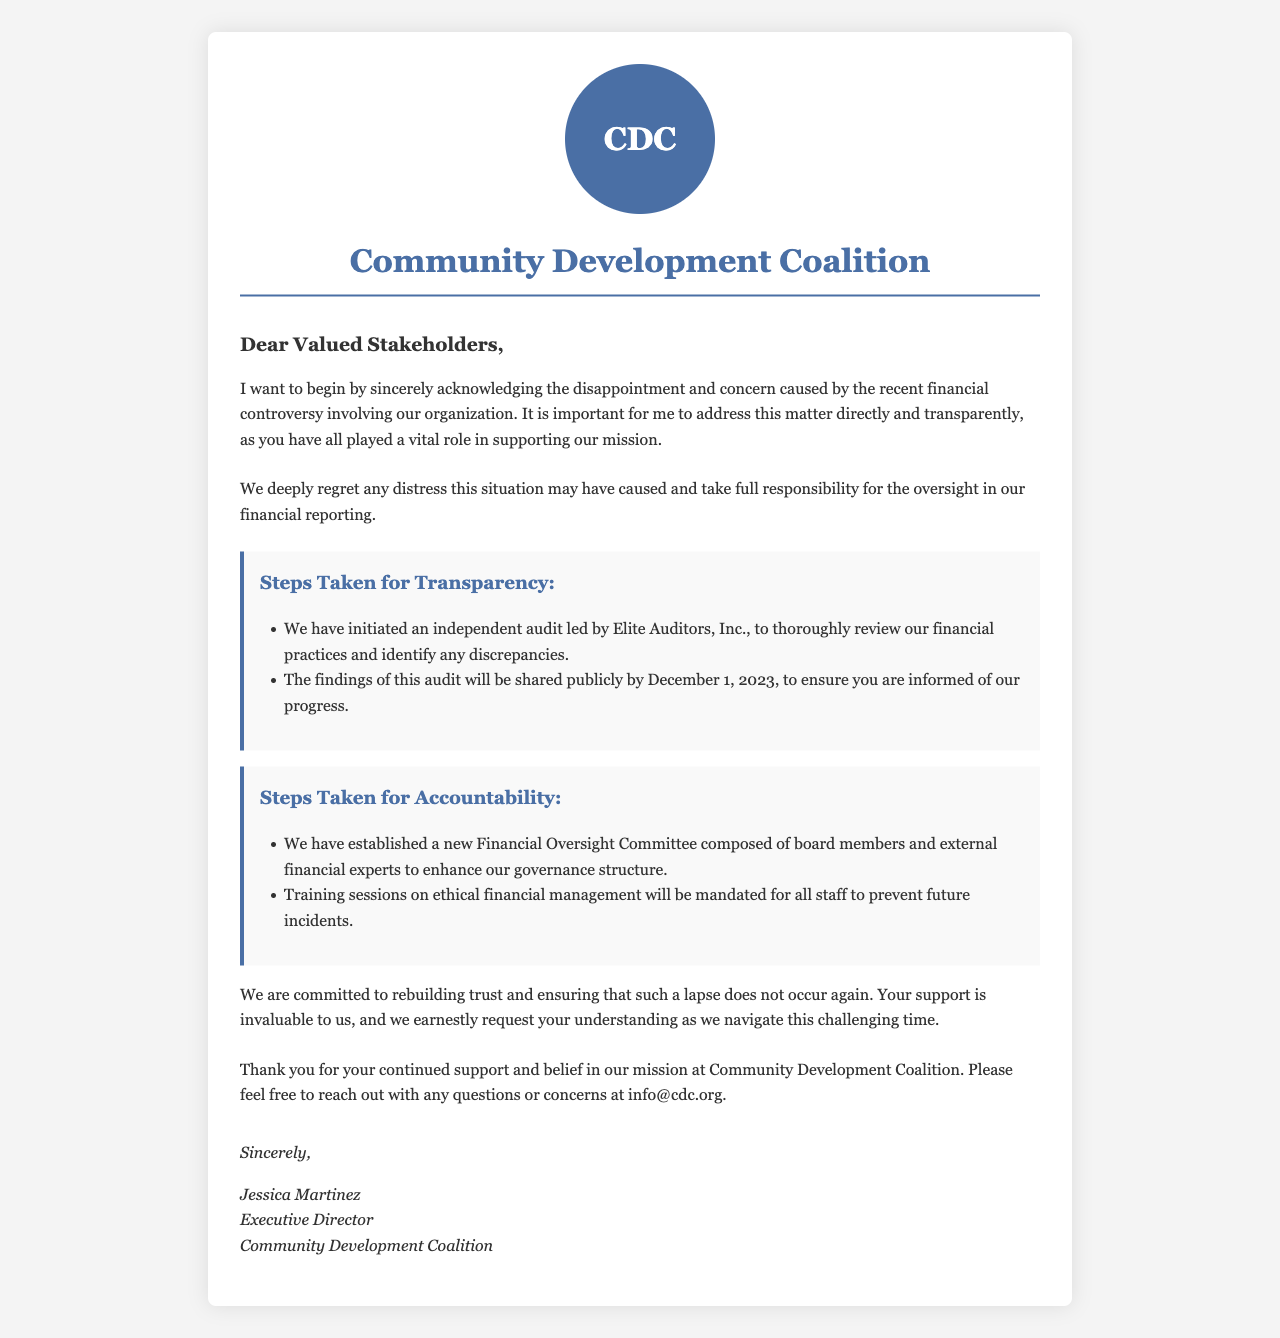what is the name of the organization? The name of the organization is mentioned in the letter header, identifying the author and organization writing to stakeholders.
Answer: Community Development Coalition who is the author of the letter? The letter concludes with the name and title of the person maintaining responsibility for the organization.
Answer: Jessica Martinez what auditing firm was engaged? The letter specifies the name of the firm conducting the audit, indicating the steps taken for transparency.
Answer: Elite Auditors, Inc when will the audit findings be shared? The document includes a specific date for when the audit findings will be made public to stakeholders.
Answer: December 1, 2023 what new committee has been established? The letter outlines a specific new committee formed to enhance financial governance in the organization.
Answer: Financial Oversight Committee how many steps are there for transparency? The letter details the number of actionable steps being taken to ensure transparency.
Answer: Two what will be mandated for all staff? This question addresses the requirements instituted for the staff to ensure future accountability in financial management.
Answer: Training sessions on ethical financial management which email address can stakeholders reach out to? The letter provides a way for stakeholders to communicate any questions or concerns.
Answer: info@cdc.org what is the primary purpose of this letter? The document outlines its intention to address a specific issue and rebuild trust with stakeholders.
Answer: Apology for the financial controversy 